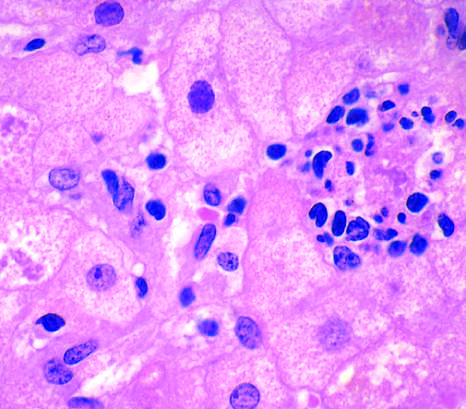s a mallory-denk body present in another hepatocyte?
Answer the question using a single word or phrase. Yes 